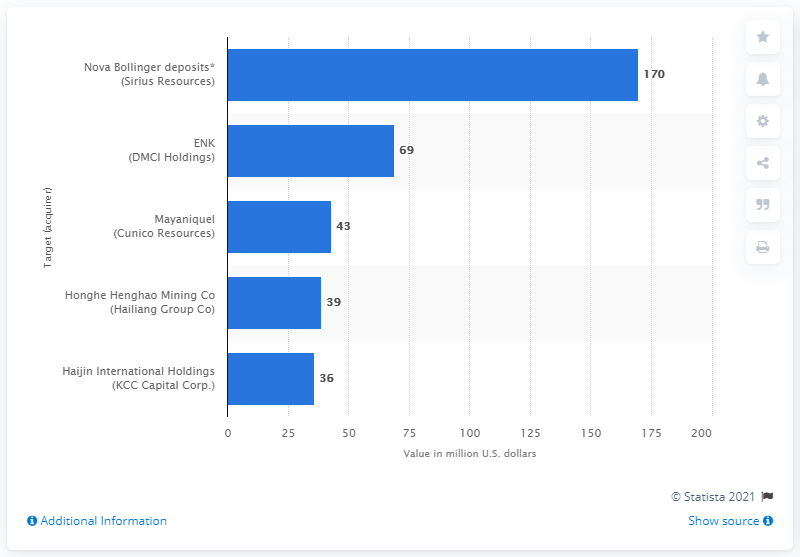Mention a couple of crucial points in this snapshot. The value of the Nova-Bollinger deposits was 170. 